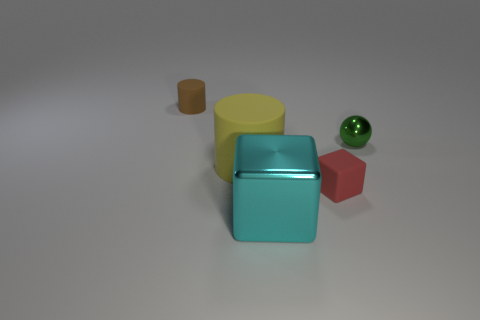Add 5 matte cylinders. How many objects exist? 10 Subtract all blocks. How many objects are left? 3 Add 3 tiny brown matte things. How many tiny brown matte things are left? 4 Add 1 green cylinders. How many green cylinders exist? 1 Subtract 0 blue spheres. How many objects are left? 5 Subtract all tiny blue cylinders. Subtract all large rubber cylinders. How many objects are left? 4 